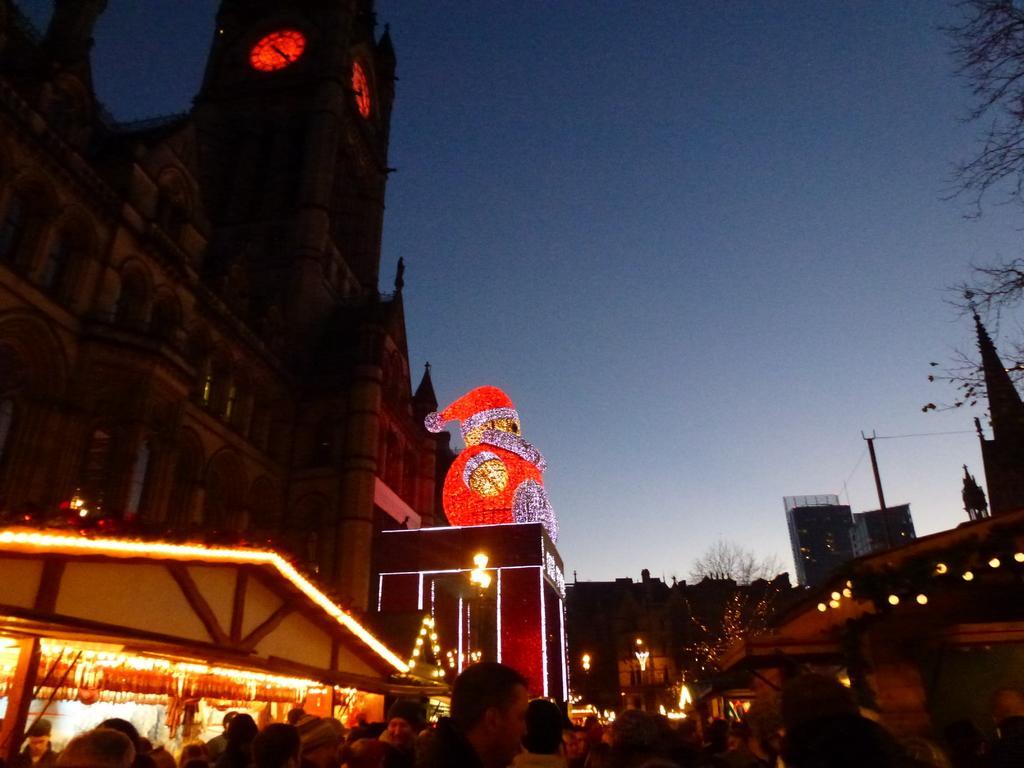Could you give a brief overview of what you see in this image? The picture is captured in the evening, there is a huge building and in front of the building there is sculpture of Santa Clause above the entrance of the building. There is a huge crowd moving around and the building is lightened up with bright lights and above the tower there are two clocks fit in between the wall, on the right side there are some other buildings and beside them there are few trees. 